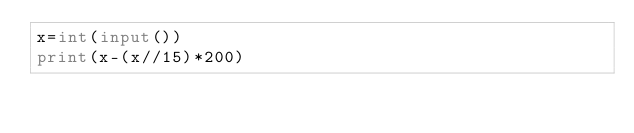<code> <loc_0><loc_0><loc_500><loc_500><_Python_>x=int(input())
print(x-(x//15)*200)</code> 